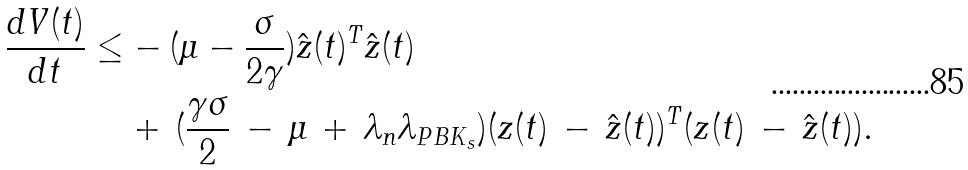Convert formula to latex. <formula><loc_0><loc_0><loc_500><loc_500>\frac { d V ( t ) } { d t } \leq & - ( \mu - \frac { \sigma } { 2 \gamma } ) \hat { z } ( t ) ^ { T } \hat { z } ( t ) \\ & + \, ( \frac { \gamma \sigma } { 2 } \, - \, \mu \, + \, \lambda _ { n } \lambda _ { P B K _ { s } } ) ( z ( t ) \, - \, \hat { z } ( t ) ) ^ { T } ( z ( t ) \, - \, \hat { z } ( t ) ) .</formula> 